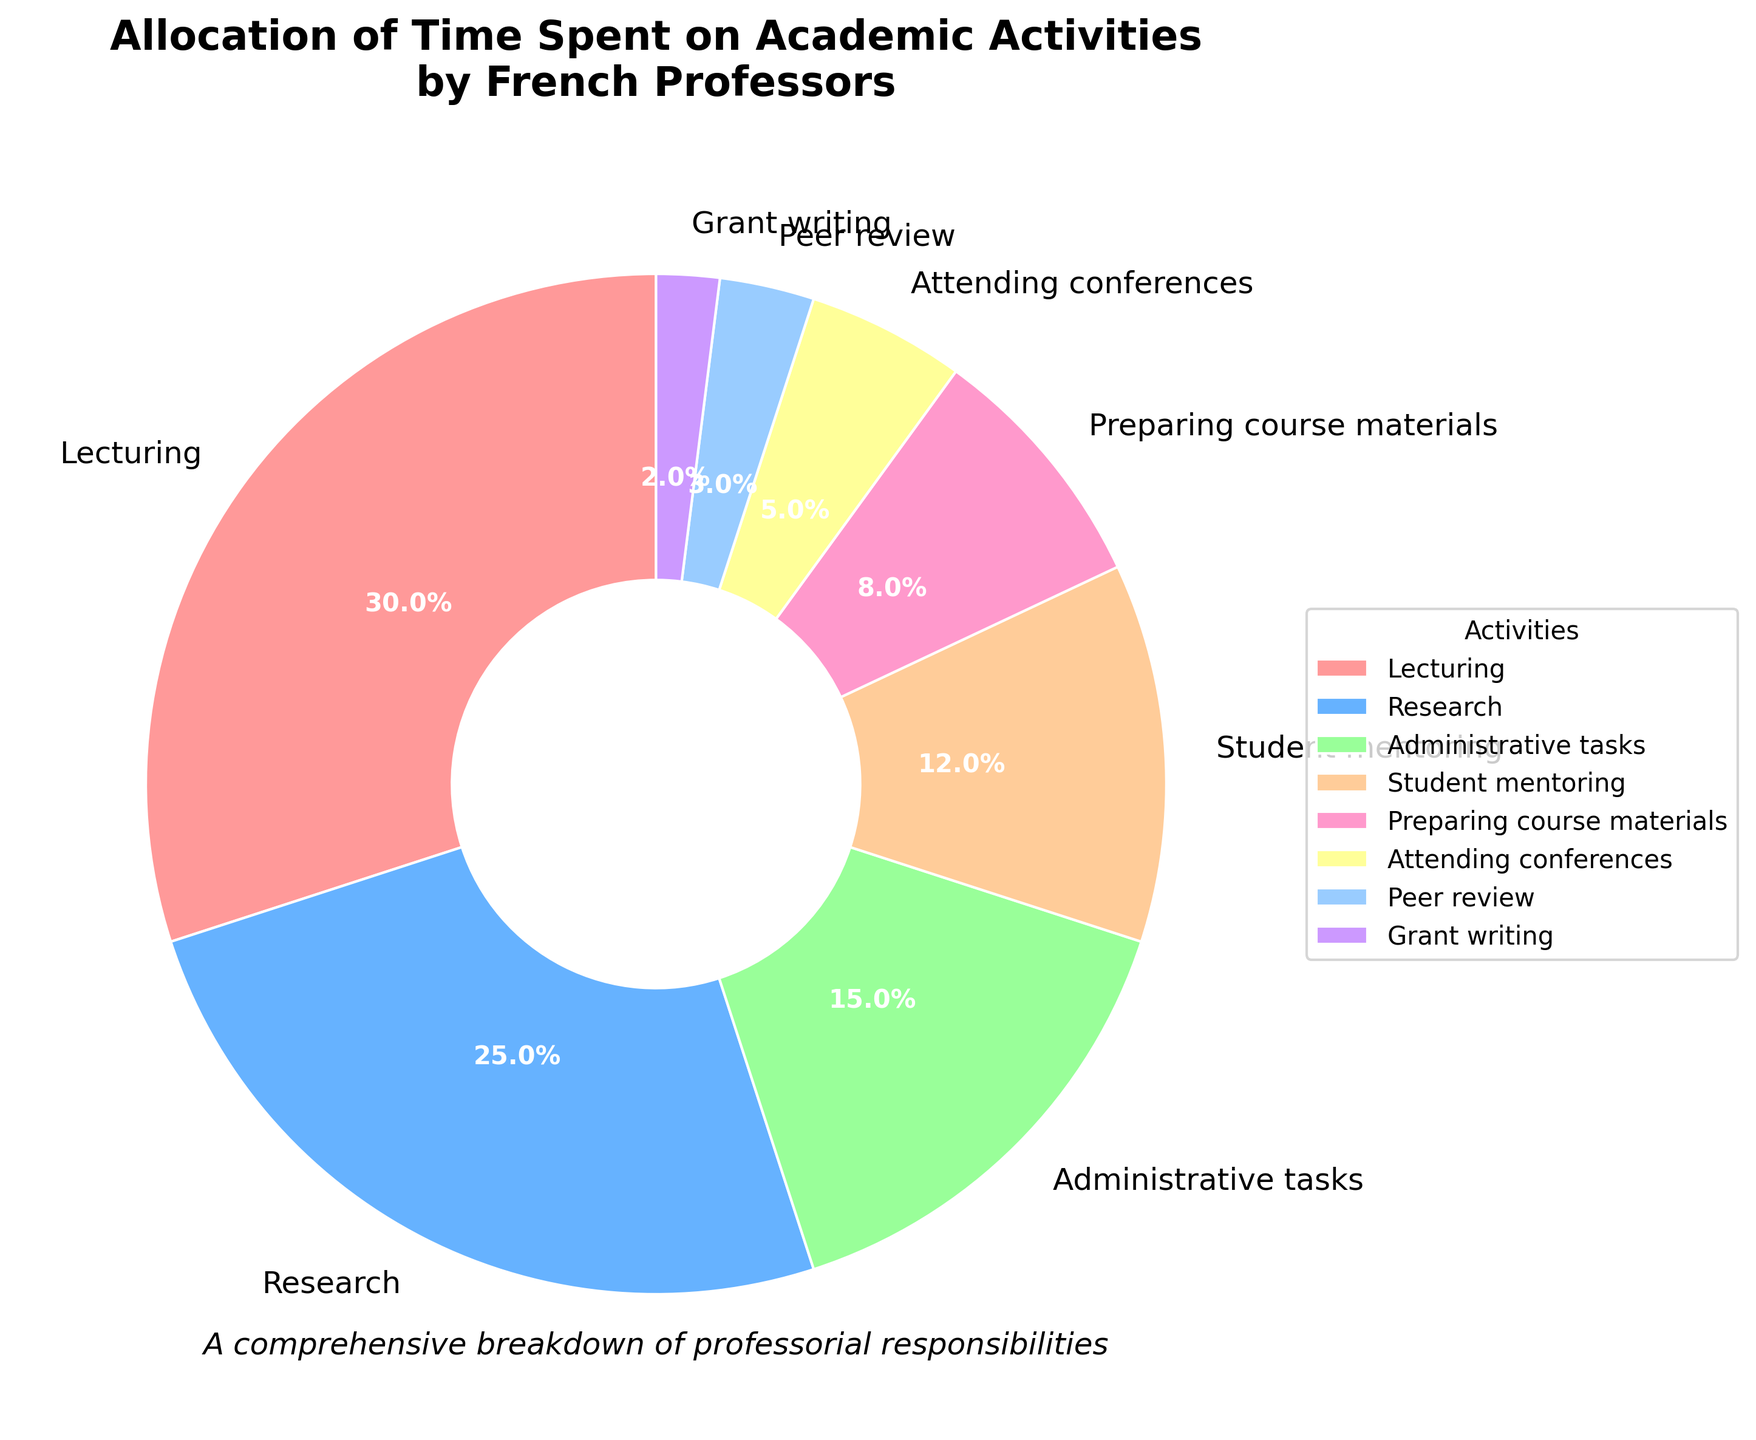What's the largest allocation of time spent on a single activity? Identify the segment with the highest percentage value. The largest segment is "Lecturing" which takes 30%.
Answer: 30% How much more time is spent on Research than on Attending conferences? Calculate the difference between the percentage of time spent on Research (25%) and Attending conferences (5%). 25% - 5% = 20%.
Answer: 20% Which activity has the smallest allocation of time? Find the segment with the smallest percentage value. The smallest segment is "Grant writing" which takes 2%.
Answer: Grant writing What is the combined percentage of time spent on Student mentoring and Preparing course materials? Add the percentages of "Student mentoring" (12%) and "Preparing course materials" (8%). 12% + 8% = 20%.
Answer: 20% Is more time spent on Administrative tasks or Peer review? Compare the percentages of time spent on Administrative tasks (15%) and Peer review (3%). 15% is greater than 3%.
Answer: Administrative tasks What proportion of the time is spent on activities other than Lecturing? Subtract the percentage of Lecturing from 100%. 100% - 30% = 70%.
Answer: 70% What is the total percentage of time spent on activities related to teaching (Lecturing and Preparing course materials)? Add the percentages of "Lecturing" (30%) and "Preparing course materials" (8%). 30% + 8% = 38%.
Answer: 38% Which activity occupies a significant but not the highest amount of time, based on the pie chart's visual attributes? The second largest segment in the chart after "Lecturing" is "Research" with 25%. It's significant but not the highest.
Answer: Research 